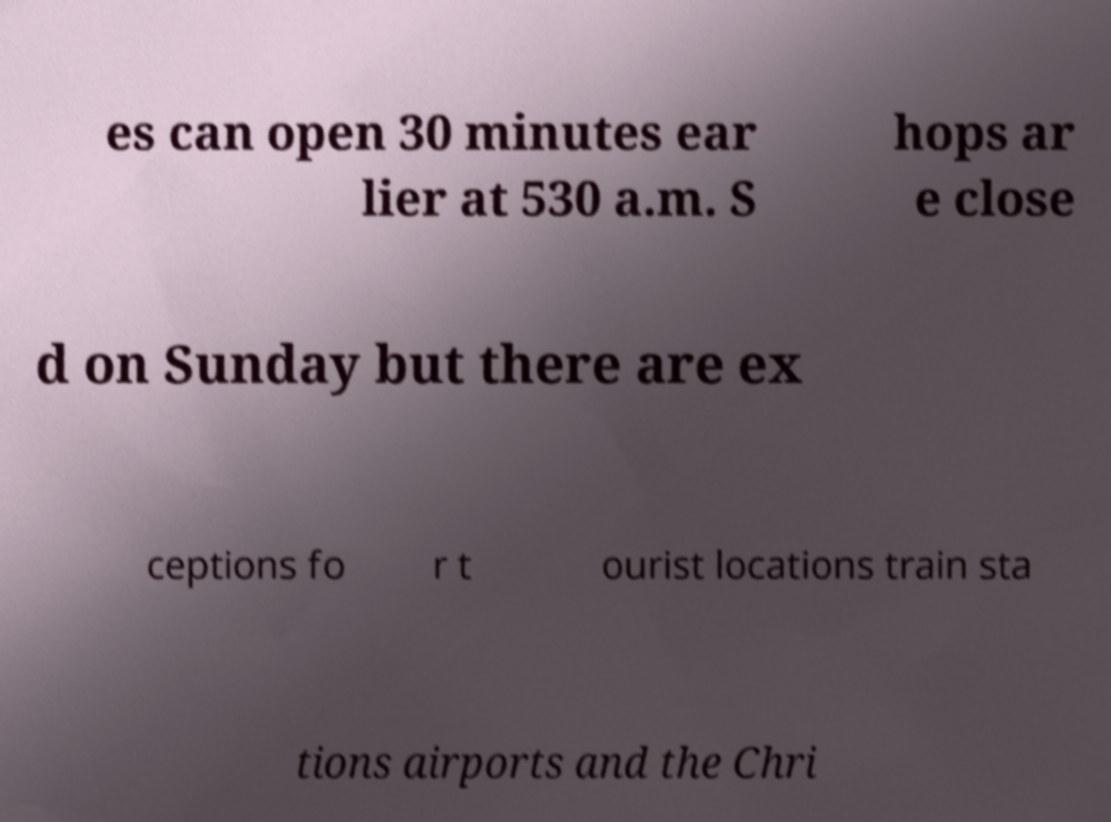Can you accurately transcribe the text from the provided image for me? es can open 30 minutes ear lier at 530 a.m. S hops ar e close d on Sunday but there are ex ceptions fo r t ourist locations train sta tions airports and the Chri 